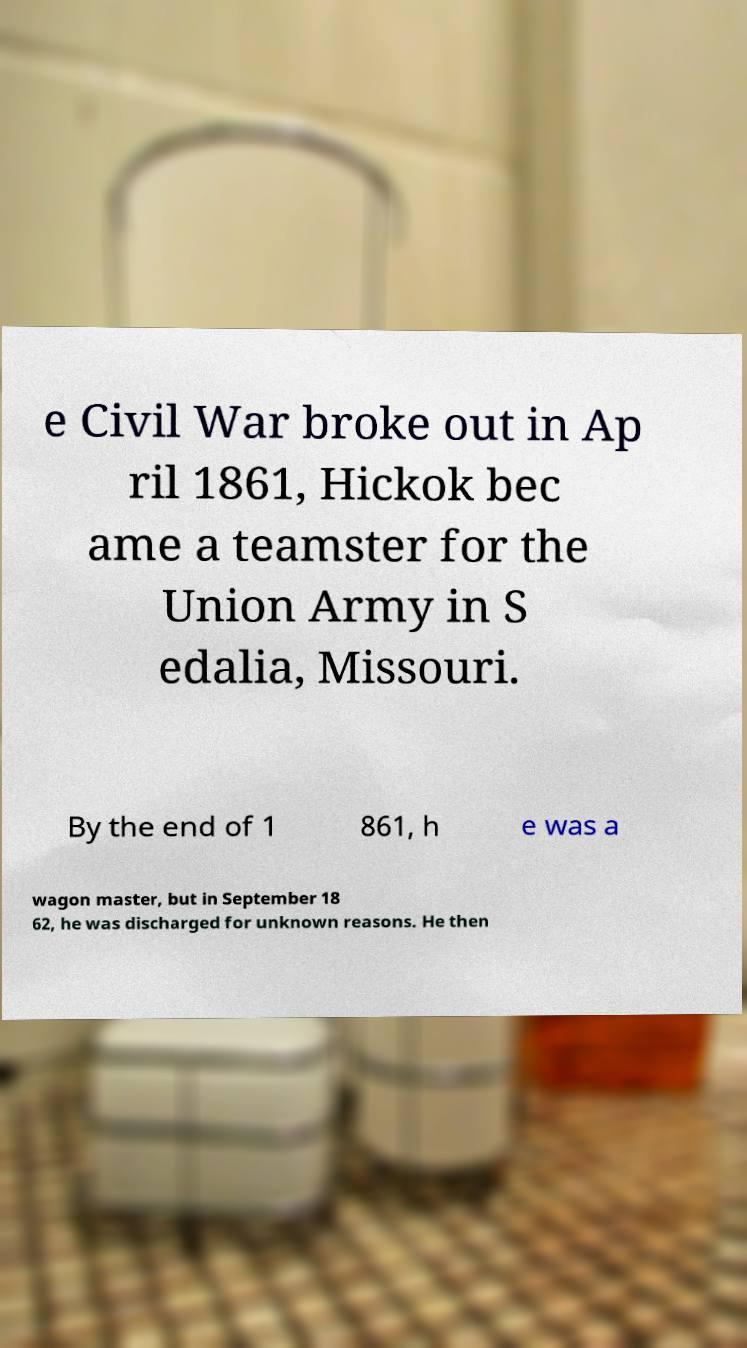Please read and relay the text visible in this image. What does it say? e Civil War broke out in Ap ril 1861, Hickok bec ame a teamster for the Union Army in S edalia, Missouri. By the end of 1 861, h e was a wagon master, but in September 18 62, he was discharged for unknown reasons. He then 